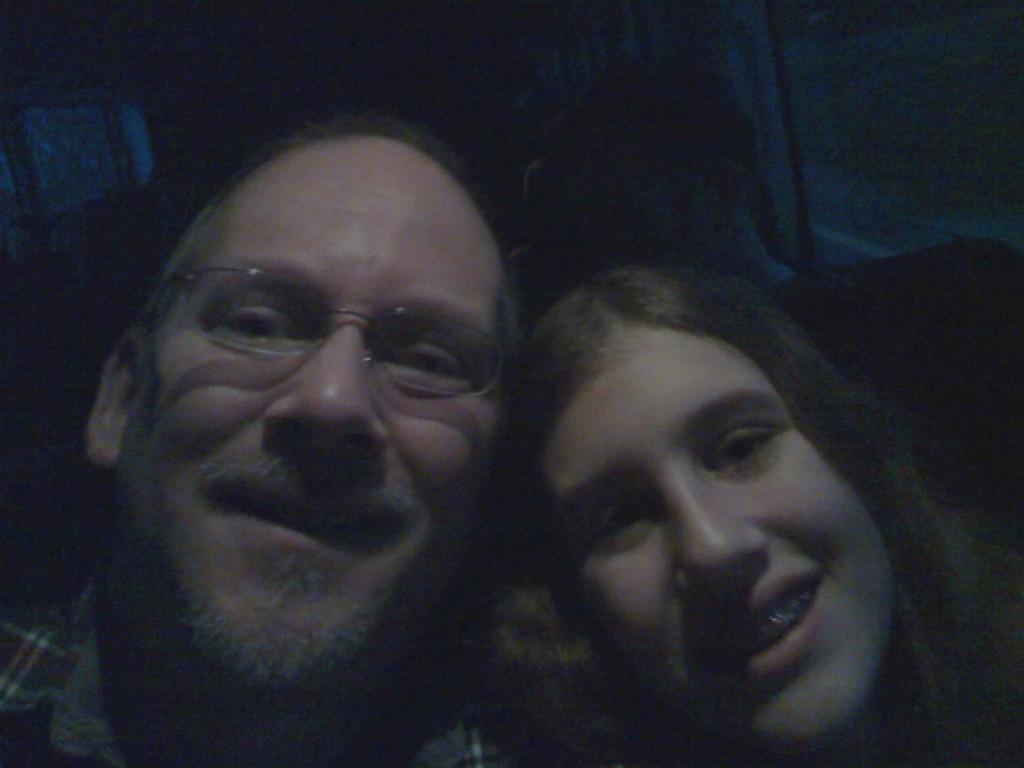In one or two sentences, can you explain what this image depicts? In the picture I can see a person wearing spectacles in the left corner and there is another woman beside him in the right corner. 